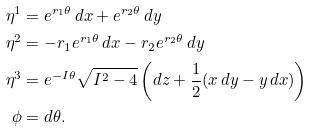<formula> <loc_0><loc_0><loc_500><loc_500>\eta ^ { 1 } & = e ^ { r _ { 1 } \theta } \, d x + e ^ { r _ { 2 } \theta } \, d y \\ \eta ^ { 2 } & = - r _ { 1 } e ^ { r _ { 1 } \theta } \, d x - r _ { 2 } e ^ { r _ { 2 } \theta } \, d y \\ \eta ^ { 3 } & = e ^ { - I \theta } \sqrt { I ^ { 2 } - 4 } \left ( d z + \frac { 1 } { 2 } ( x \, d y - y \, d x ) \right ) \\ \phi & = d \theta .</formula> 